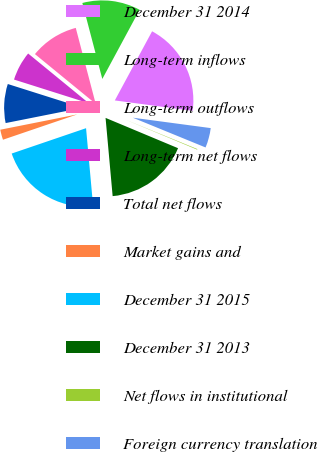Convert chart. <chart><loc_0><loc_0><loc_500><loc_500><pie_chart><fcel>December 31 2014<fcel>Long-term inflows<fcel>Long-term outflows<fcel>Long-term net flows<fcel>Total net flows<fcel>Market gains and<fcel>December 31 2015<fcel>December 31 2013<fcel>Net flows in institutional<fcel>Foreign currency translation<nl><fcel>19.24%<fcel>11.96%<fcel>9.99%<fcel>6.04%<fcel>8.01%<fcel>2.1%<fcel>21.21%<fcel>17.26%<fcel>0.12%<fcel>4.07%<nl></chart> 